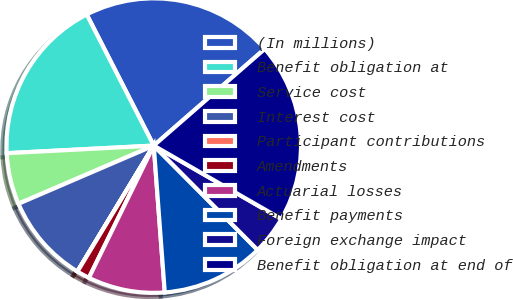<chart> <loc_0><loc_0><loc_500><loc_500><pie_chart><fcel>(In millions)<fcel>Benefit obligation at<fcel>Service cost<fcel>Interest cost<fcel>Participant contributions<fcel>Amendments<fcel>Actuarial losses<fcel>Benefit payments<fcel>Foreign exchange impact<fcel>Benefit obligation at end of<nl><fcel>21.12%<fcel>18.3%<fcel>5.64%<fcel>9.86%<fcel>0.01%<fcel>1.41%<fcel>8.45%<fcel>11.27%<fcel>4.23%<fcel>19.71%<nl></chart> 